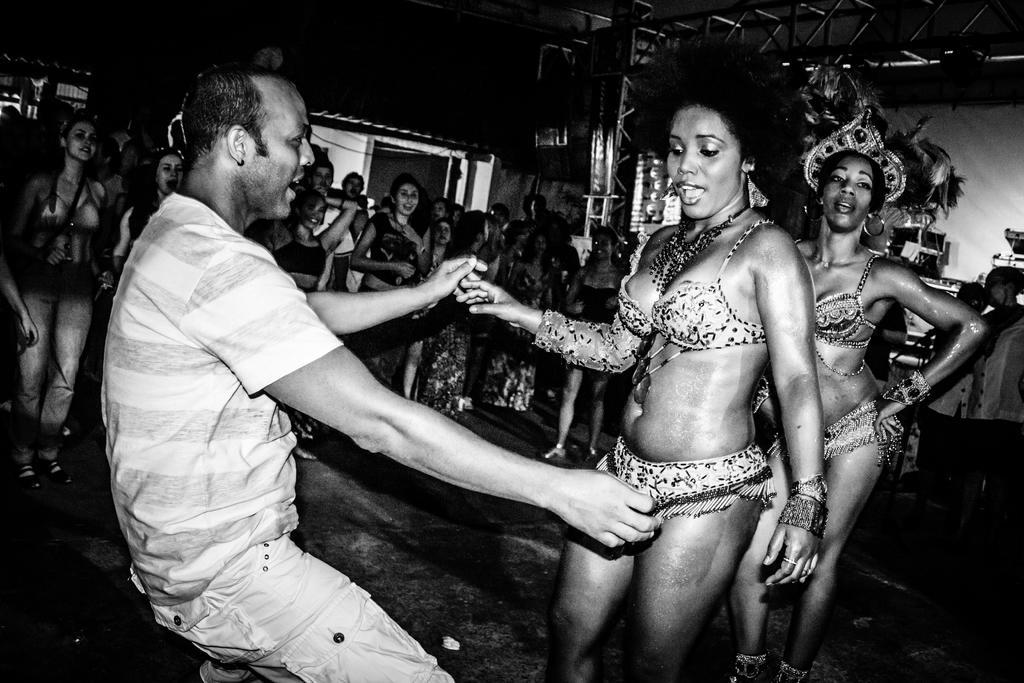Describe this image in one or two sentences. This is black and white picture, there is a man in t-shirt and jeans holding a woman in bikini and in the back there are many woman standing in bikini, it seems to be a fashion show and above there is a metal frame to the ceiling. 